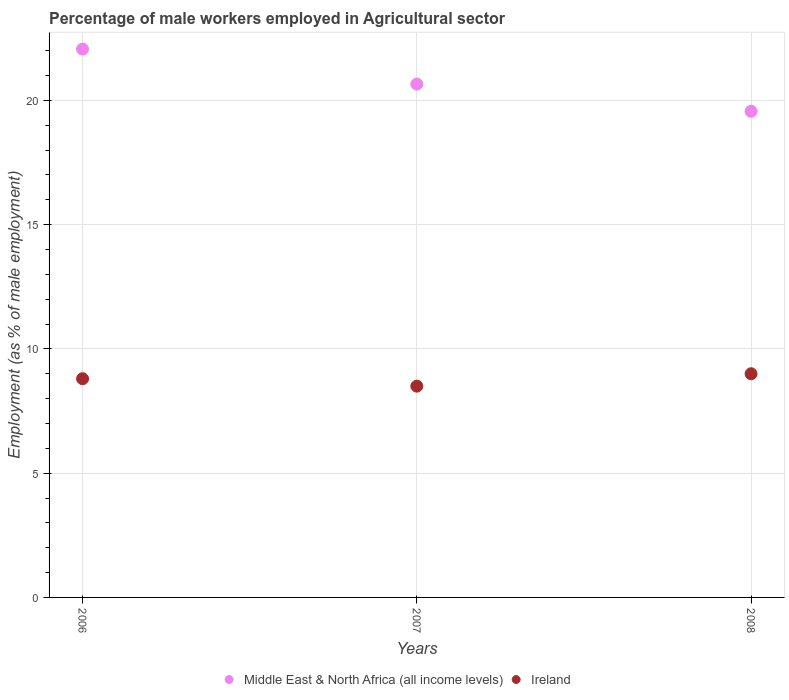Is the number of dotlines equal to the number of legend labels?
Offer a very short reply. Yes. Across all years, what is the maximum percentage of male workers employed in Agricultural sector in Middle East & North Africa (all income levels)?
Provide a succinct answer. 22.06. Across all years, what is the minimum percentage of male workers employed in Agricultural sector in Middle East & North Africa (all income levels)?
Offer a very short reply. 19.56. What is the total percentage of male workers employed in Agricultural sector in Ireland in the graph?
Your response must be concise. 26.3. What is the difference between the percentage of male workers employed in Agricultural sector in Ireland in 2007 and that in 2008?
Your response must be concise. -0.5. What is the difference between the percentage of male workers employed in Agricultural sector in Ireland in 2007 and the percentage of male workers employed in Agricultural sector in Middle East & North Africa (all income levels) in 2008?
Make the answer very short. -11.06. What is the average percentage of male workers employed in Agricultural sector in Middle East & North Africa (all income levels) per year?
Offer a very short reply. 20.76. In the year 2007, what is the difference between the percentage of male workers employed in Agricultural sector in Ireland and percentage of male workers employed in Agricultural sector in Middle East & North Africa (all income levels)?
Your response must be concise. -12.15. In how many years, is the percentage of male workers employed in Agricultural sector in Middle East & North Africa (all income levels) greater than 4 %?
Give a very brief answer. 3. What is the ratio of the percentage of male workers employed in Agricultural sector in Ireland in 2006 to that in 2008?
Offer a very short reply. 0.98. Is the difference between the percentage of male workers employed in Agricultural sector in Ireland in 2006 and 2008 greater than the difference between the percentage of male workers employed in Agricultural sector in Middle East & North Africa (all income levels) in 2006 and 2008?
Your answer should be very brief. No. What is the difference between the highest and the second highest percentage of male workers employed in Agricultural sector in Ireland?
Your answer should be very brief. 0.2. What is the difference between the highest and the lowest percentage of male workers employed in Agricultural sector in Ireland?
Keep it short and to the point. 0.5. In how many years, is the percentage of male workers employed in Agricultural sector in Middle East & North Africa (all income levels) greater than the average percentage of male workers employed in Agricultural sector in Middle East & North Africa (all income levels) taken over all years?
Offer a very short reply. 1. Is the percentage of male workers employed in Agricultural sector in Ireland strictly less than the percentage of male workers employed in Agricultural sector in Middle East & North Africa (all income levels) over the years?
Offer a terse response. Yes. How many dotlines are there?
Your answer should be very brief. 2. What is the difference between two consecutive major ticks on the Y-axis?
Keep it short and to the point. 5. Are the values on the major ticks of Y-axis written in scientific E-notation?
Give a very brief answer. No. Where does the legend appear in the graph?
Give a very brief answer. Bottom center. How are the legend labels stacked?
Offer a very short reply. Horizontal. What is the title of the graph?
Give a very brief answer. Percentage of male workers employed in Agricultural sector. Does "Comoros" appear as one of the legend labels in the graph?
Ensure brevity in your answer.  No. What is the label or title of the X-axis?
Give a very brief answer. Years. What is the label or title of the Y-axis?
Provide a succinct answer. Employment (as % of male employment). What is the Employment (as % of male employment) of Middle East & North Africa (all income levels) in 2006?
Ensure brevity in your answer.  22.06. What is the Employment (as % of male employment) in Ireland in 2006?
Your answer should be compact. 8.8. What is the Employment (as % of male employment) in Middle East & North Africa (all income levels) in 2007?
Make the answer very short. 20.65. What is the Employment (as % of male employment) of Middle East & North Africa (all income levels) in 2008?
Offer a terse response. 19.56. What is the Employment (as % of male employment) in Ireland in 2008?
Offer a very short reply. 9. Across all years, what is the maximum Employment (as % of male employment) of Middle East & North Africa (all income levels)?
Provide a short and direct response. 22.06. Across all years, what is the minimum Employment (as % of male employment) in Middle East & North Africa (all income levels)?
Your answer should be compact. 19.56. What is the total Employment (as % of male employment) in Middle East & North Africa (all income levels) in the graph?
Provide a short and direct response. 62.28. What is the total Employment (as % of male employment) of Ireland in the graph?
Your answer should be compact. 26.3. What is the difference between the Employment (as % of male employment) of Middle East & North Africa (all income levels) in 2006 and that in 2007?
Ensure brevity in your answer.  1.41. What is the difference between the Employment (as % of male employment) in Ireland in 2006 and that in 2007?
Make the answer very short. 0.3. What is the difference between the Employment (as % of male employment) in Middle East & North Africa (all income levels) in 2006 and that in 2008?
Your answer should be compact. 2.5. What is the difference between the Employment (as % of male employment) of Middle East & North Africa (all income levels) in 2007 and that in 2008?
Provide a short and direct response. 1.09. What is the difference between the Employment (as % of male employment) of Middle East & North Africa (all income levels) in 2006 and the Employment (as % of male employment) of Ireland in 2007?
Offer a very short reply. 13.56. What is the difference between the Employment (as % of male employment) in Middle East & North Africa (all income levels) in 2006 and the Employment (as % of male employment) in Ireland in 2008?
Ensure brevity in your answer.  13.06. What is the difference between the Employment (as % of male employment) in Middle East & North Africa (all income levels) in 2007 and the Employment (as % of male employment) in Ireland in 2008?
Keep it short and to the point. 11.65. What is the average Employment (as % of male employment) of Middle East & North Africa (all income levels) per year?
Make the answer very short. 20.76. What is the average Employment (as % of male employment) of Ireland per year?
Ensure brevity in your answer.  8.77. In the year 2006, what is the difference between the Employment (as % of male employment) of Middle East & North Africa (all income levels) and Employment (as % of male employment) of Ireland?
Provide a short and direct response. 13.26. In the year 2007, what is the difference between the Employment (as % of male employment) in Middle East & North Africa (all income levels) and Employment (as % of male employment) in Ireland?
Your answer should be compact. 12.15. In the year 2008, what is the difference between the Employment (as % of male employment) in Middle East & North Africa (all income levels) and Employment (as % of male employment) in Ireland?
Give a very brief answer. 10.56. What is the ratio of the Employment (as % of male employment) of Middle East & North Africa (all income levels) in 2006 to that in 2007?
Provide a succinct answer. 1.07. What is the ratio of the Employment (as % of male employment) in Ireland in 2006 to that in 2007?
Provide a short and direct response. 1.04. What is the ratio of the Employment (as % of male employment) in Middle East & North Africa (all income levels) in 2006 to that in 2008?
Offer a terse response. 1.13. What is the ratio of the Employment (as % of male employment) of Ireland in 2006 to that in 2008?
Your answer should be very brief. 0.98. What is the ratio of the Employment (as % of male employment) in Middle East & North Africa (all income levels) in 2007 to that in 2008?
Your response must be concise. 1.06. What is the ratio of the Employment (as % of male employment) in Ireland in 2007 to that in 2008?
Give a very brief answer. 0.94. What is the difference between the highest and the second highest Employment (as % of male employment) in Middle East & North Africa (all income levels)?
Provide a succinct answer. 1.41. What is the difference between the highest and the second highest Employment (as % of male employment) in Ireland?
Your answer should be very brief. 0.2. What is the difference between the highest and the lowest Employment (as % of male employment) in Middle East & North Africa (all income levels)?
Ensure brevity in your answer.  2.5. What is the difference between the highest and the lowest Employment (as % of male employment) in Ireland?
Provide a short and direct response. 0.5. 